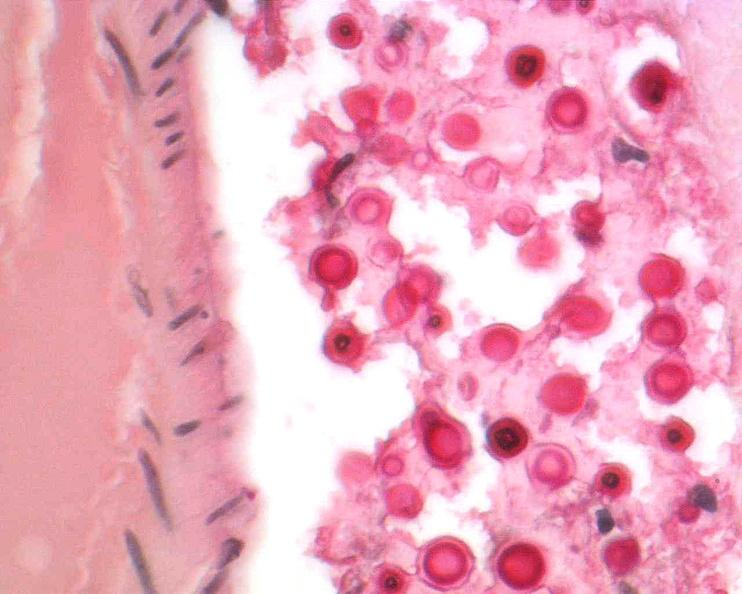does this image show brain, cryptococcal meningitis?
Answer the question using a single word or phrase. Yes 